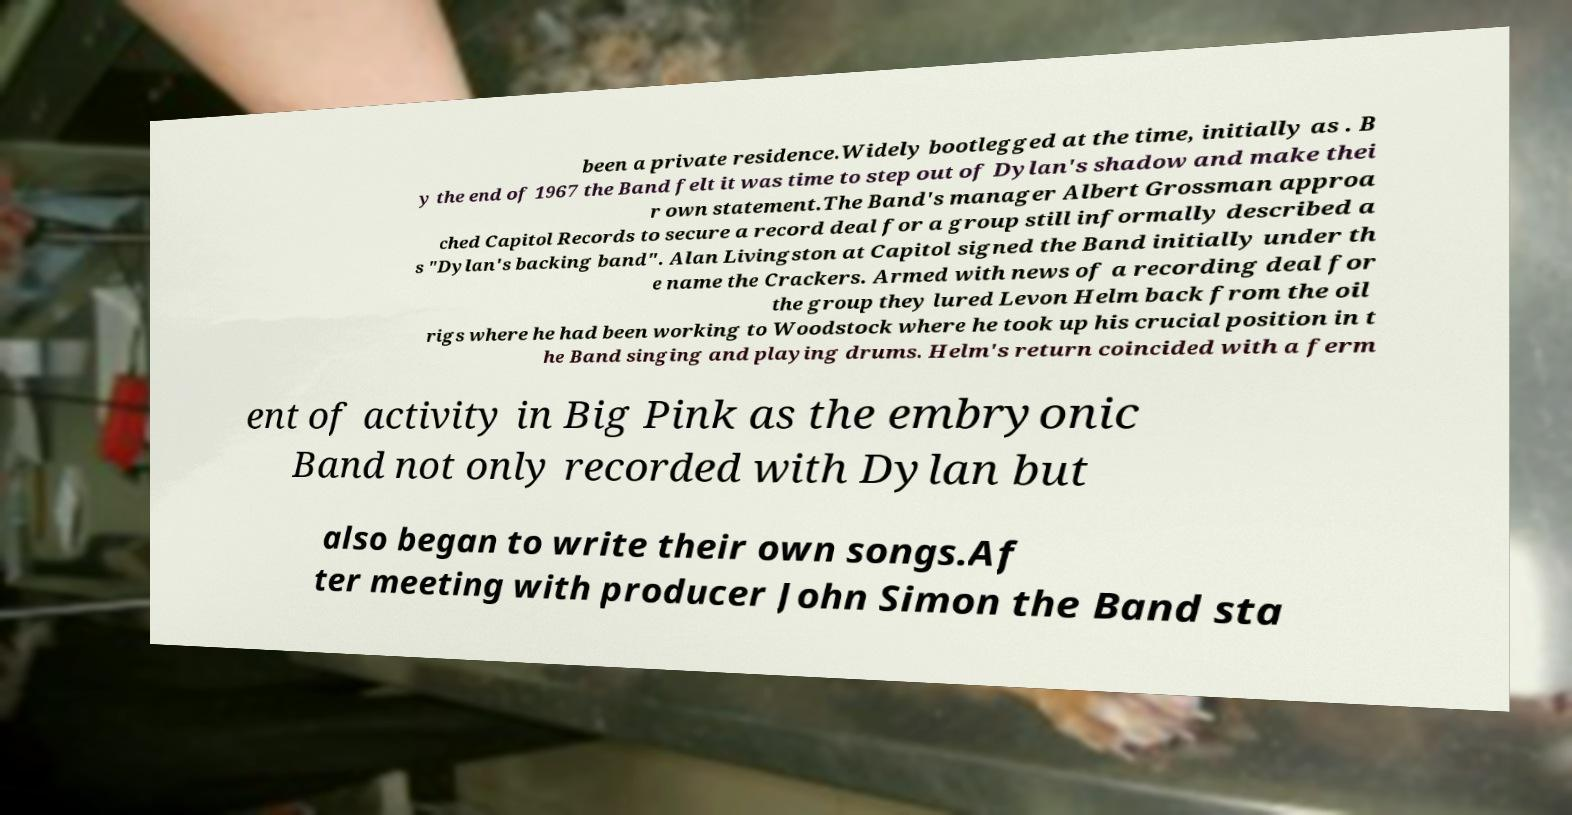Can you accurately transcribe the text from the provided image for me? been a private residence.Widely bootlegged at the time, initially as . B y the end of 1967 the Band felt it was time to step out of Dylan's shadow and make thei r own statement.The Band's manager Albert Grossman approa ched Capitol Records to secure a record deal for a group still informally described a s "Dylan's backing band". Alan Livingston at Capitol signed the Band initially under th e name the Crackers. Armed with news of a recording deal for the group they lured Levon Helm back from the oil rigs where he had been working to Woodstock where he took up his crucial position in t he Band singing and playing drums. Helm's return coincided with a ferm ent of activity in Big Pink as the embryonic Band not only recorded with Dylan but also began to write their own songs.Af ter meeting with producer John Simon the Band sta 